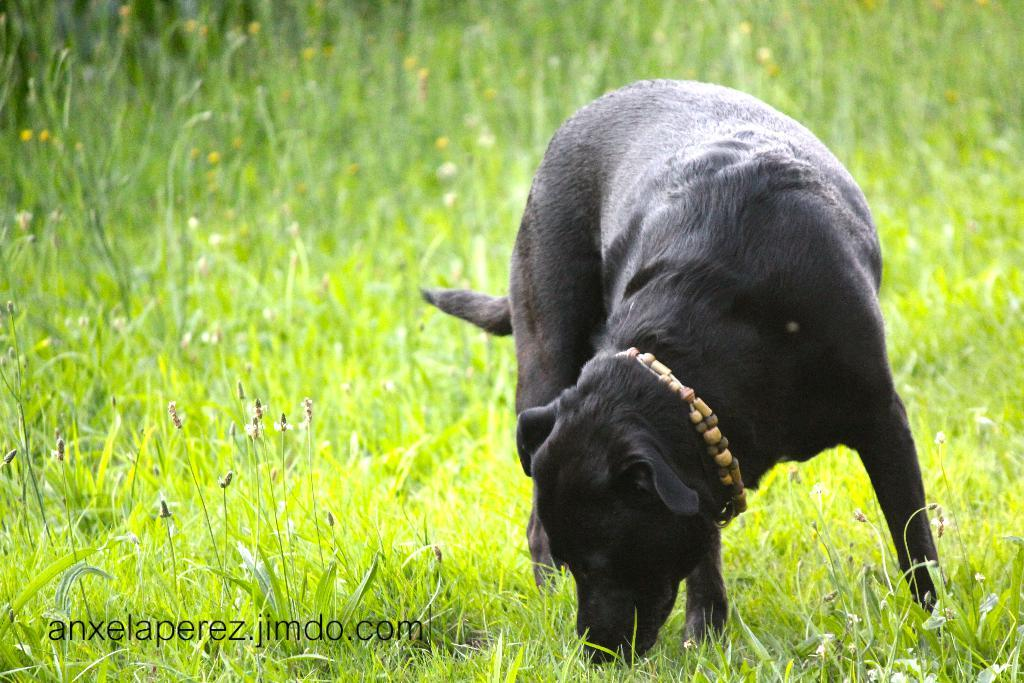What type of animal is in the image? There is a dog in the image. What is the dog standing on? The dog is standing on the grass. Can you describe any other objects or elements at the bottom of the image? Unfortunately, the provided facts do not give any information about other objects or elements at the bottom of the image. What type of flower is the dog smelling in the image? There is no flower present in the image, so it is not possible to determine what type of flower the dog might be smelling. 